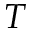<formula> <loc_0><loc_0><loc_500><loc_500>T</formula> 